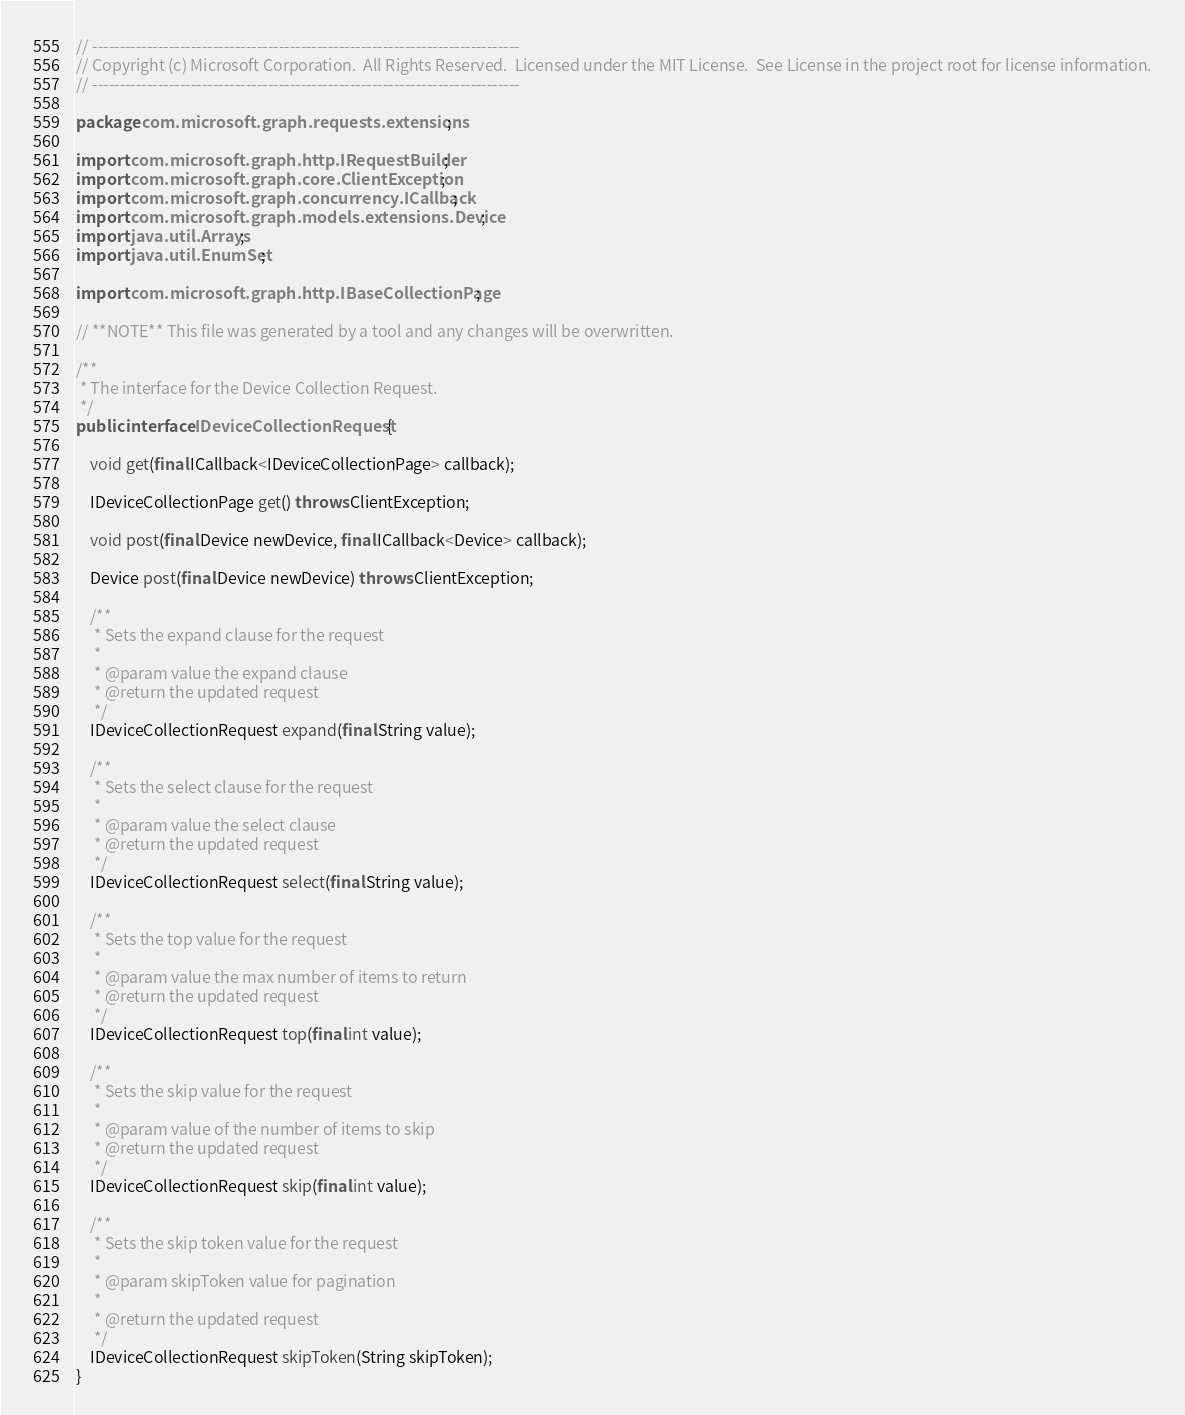Convert code to text. <code><loc_0><loc_0><loc_500><loc_500><_Java_>// ------------------------------------------------------------------------------
// Copyright (c) Microsoft Corporation.  All Rights Reserved.  Licensed under the MIT License.  See License in the project root for license information.
// ------------------------------------------------------------------------------

package com.microsoft.graph.requests.extensions;

import com.microsoft.graph.http.IRequestBuilder;
import com.microsoft.graph.core.ClientException;
import com.microsoft.graph.concurrency.ICallback;
import com.microsoft.graph.models.extensions.Device;
import java.util.Arrays;
import java.util.EnumSet;

import com.microsoft.graph.http.IBaseCollectionPage;

// **NOTE** This file was generated by a tool and any changes will be overwritten.

/**
 * The interface for the Device Collection Request.
 */
public interface IDeviceCollectionRequest {

    void get(final ICallback<IDeviceCollectionPage> callback);

    IDeviceCollectionPage get() throws ClientException;

    void post(final Device newDevice, final ICallback<Device> callback);

    Device post(final Device newDevice) throws ClientException;

    /**
     * Sets the expand clause for the request
     *
     * @param value the expand clause
     * @return the updated request
     */
    IDeviceCollectionRequest expand(final String value);

    /**
     * Sets the select clause for the request
     *
     * @param value the select clause
     * @return the updated request
     */
    IDeviceCollectionRequest select(final String value);

    /**
     * Sets the top value for the request
     *
     * @param value the max number of items to return
     * @return the updated request
     */
    IDeviceCollectionRequest top(final int value);

    /**
     * Sets the skip value for the request
     *
     * @param value of the number of items to skip
     * @return the updated request
     */
    IDeviceCollectionRequest skip(final int value);

    /**
	 * Sets the skip token value for the request
	 * 
	 * @param skipToken value for pagination
     *
	 * @return the updated request
	 */
	IDeviceCollectionRequest skipToken(String skipToken);
}
</code> 